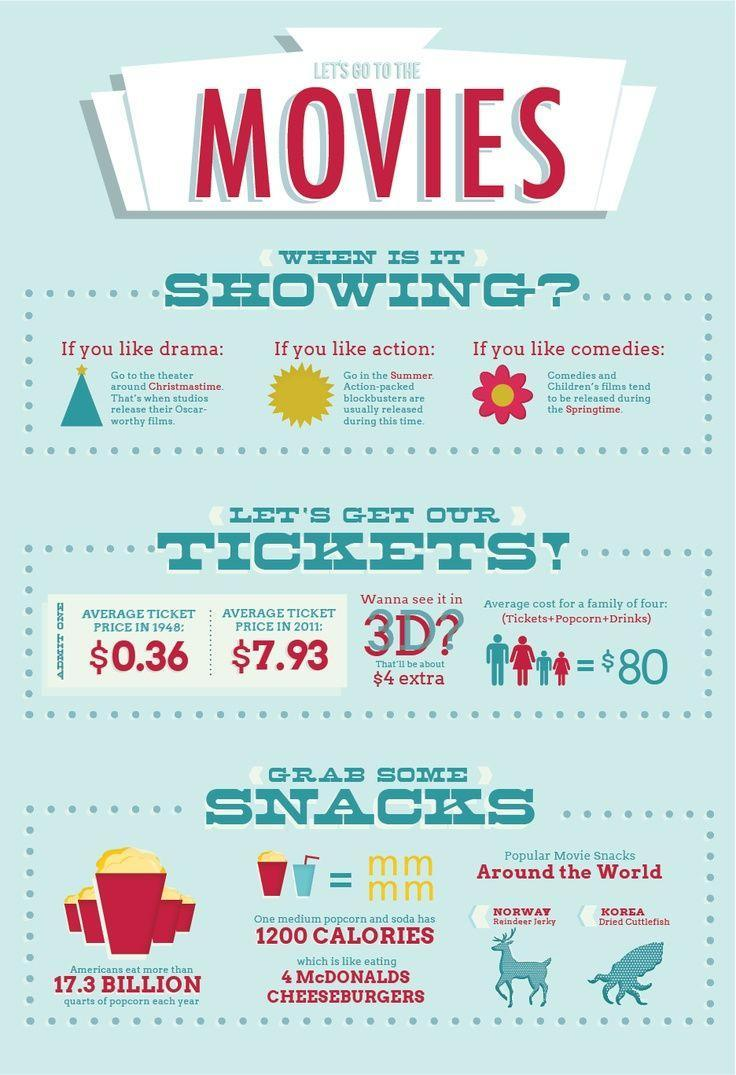what is the popular movie snack in Korea
Answer the question with a short phrase. dried cuttlefish when are oscar worthy films released christmastime calories in one medium popcorn and soda is equal to what 4 McDonalds Cheeseburgers when is it best to see drama christmastime How much did ticket price increase by 2011 7.57 what is the average cost for a family of four $80 What is released in Springtime Comedies What is the best time for action Summer 